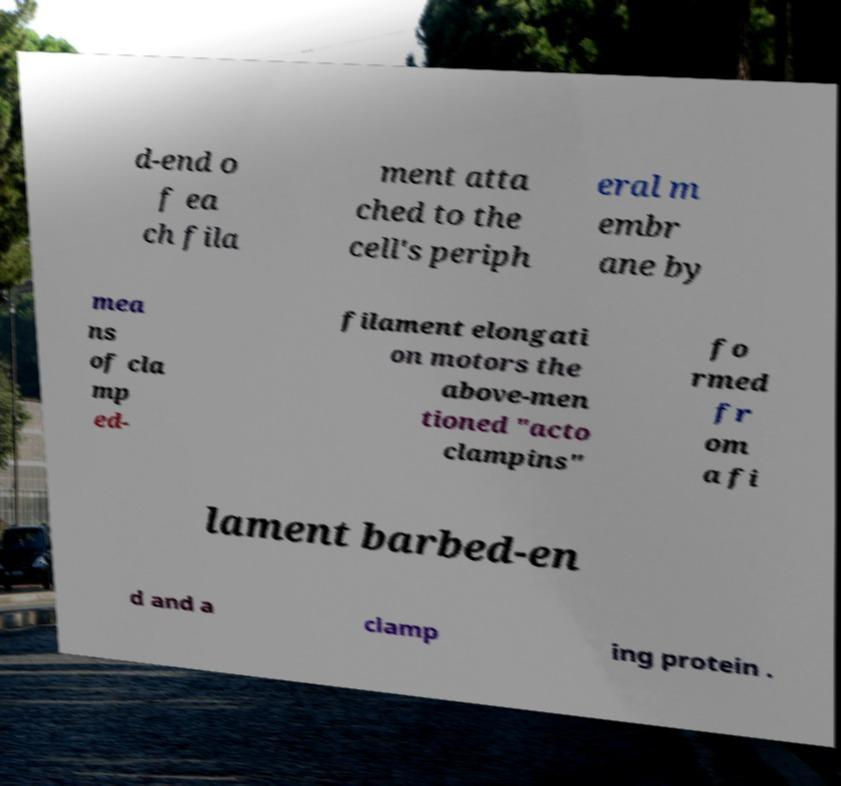I need the written content from this picture converted into text. Can you do that? d-end o f ea ch fila ment atta ched to the cell's periph eral m embr ane by mea ns of cla mp ed- filament elongati on motors the above-men tioned "acto clampins" fo rmed fr om a fi lament barbed-en d and a clamp ing protein . 